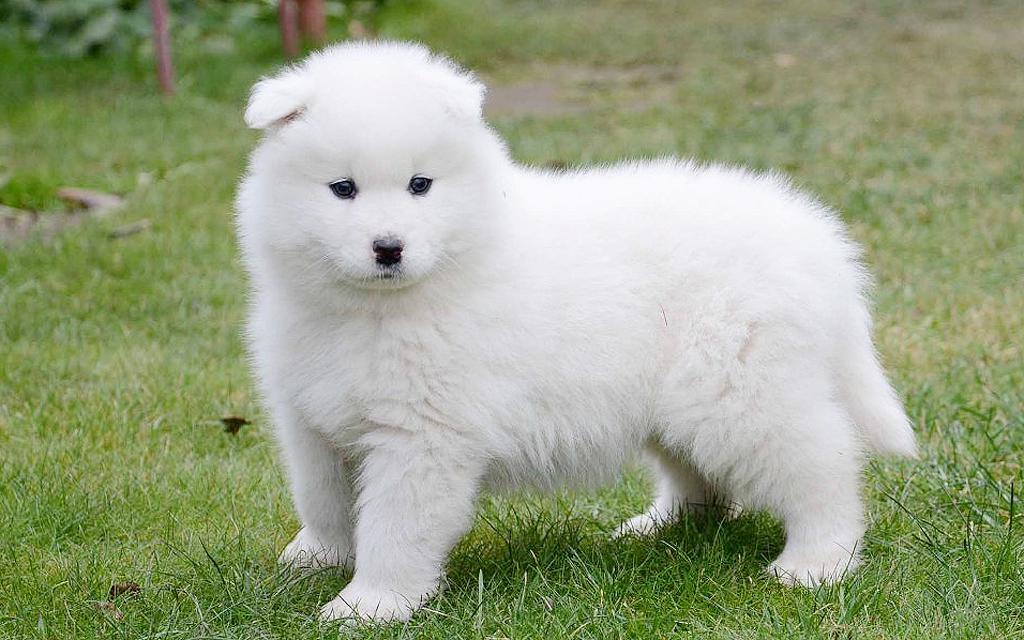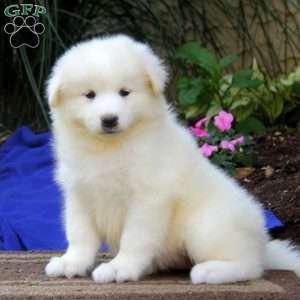The first image is the image on the left, the second image is the image on the right. For the images displayed, is the sentence "There are four dogs." factually correct? Answer yes or no. No. The first image is the image on the left, the second image is the image on the right. Analyze the images presented: Is the assertion "The left image contains at least two white dogs." valid? Answer yes or no. No. The first image is the image on the left, the second image is the image on the right. For the images displayed, is the sentence "Each image contains exactly one white dog, and one of the dogs is standing on all fours." factually correct? Answer yes or no. Yes. 